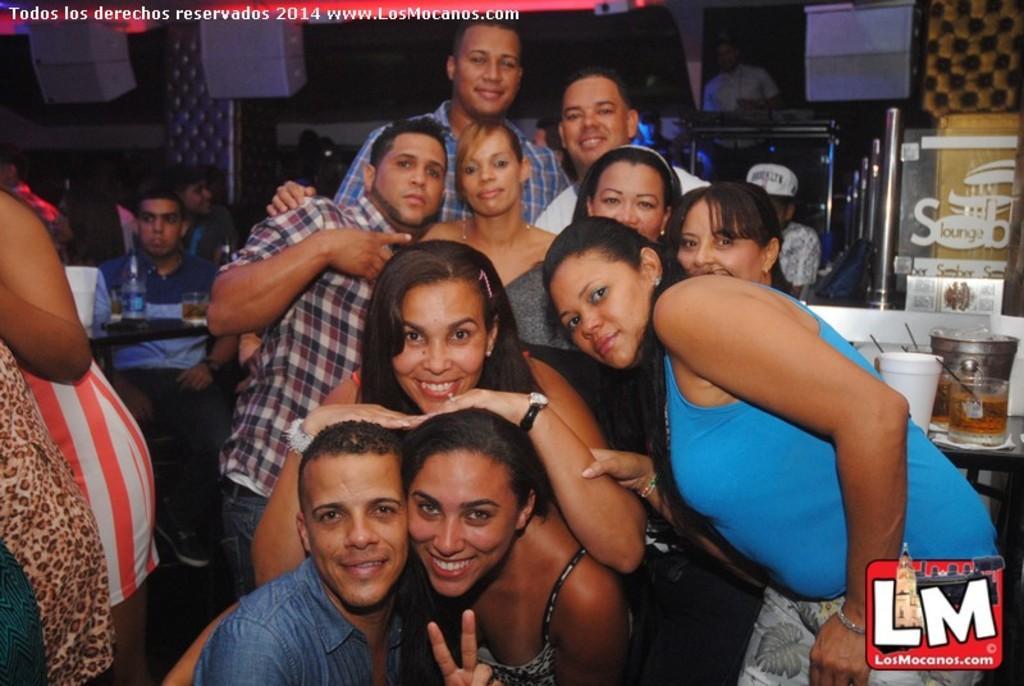How would you summarize this image in a sentence or two? As we can see in the picture there are group of people both male and female are posing for a photo. A man sitting on a chair. On the table there is a wine glass and a water bottle. The women wearing watch and band on the other hand. 